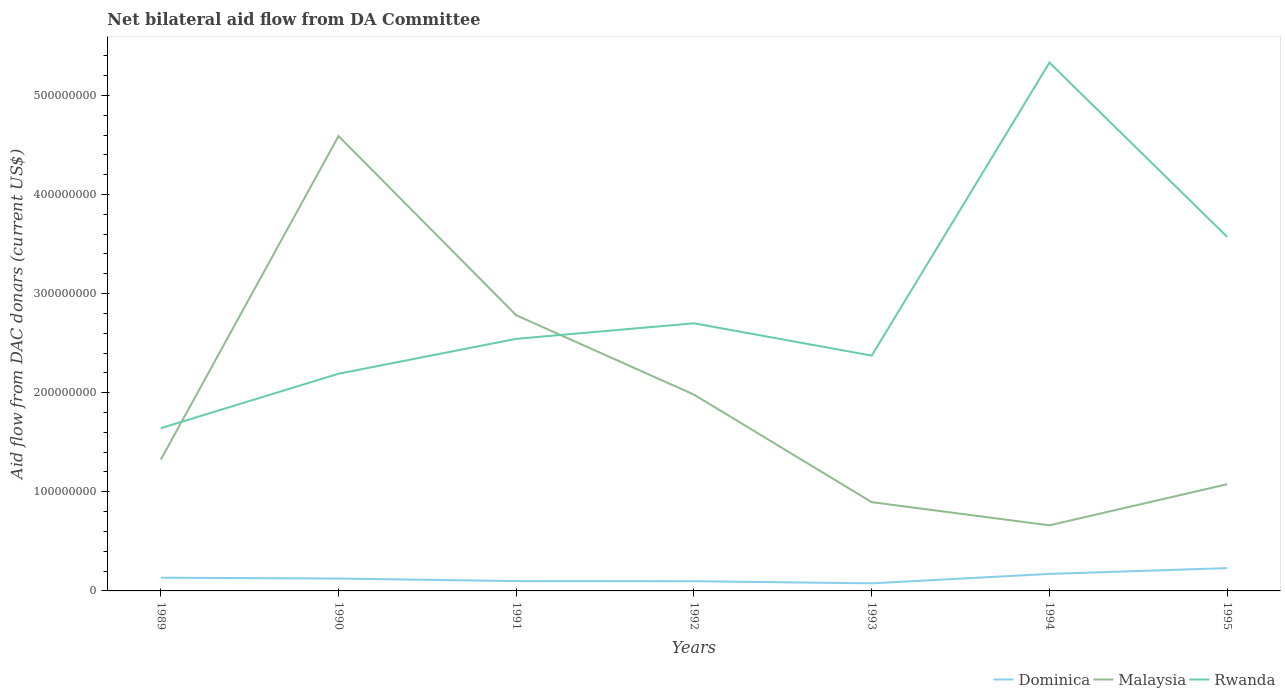Across all years, what is the maximum aid flow in in Rwanda?
Your response must be concise. 1.64e+08. In which year was the aid flow in in Rwanda maximum?
Your response must be concise. 1989. What is the total aid flow in in Dominica in the graph?
Offer a terse response. -1.54e+07. What is the difference between the highest and the second highest aid flow in in Dominica?
Give a very brief answer. 1.54e+07. Is the aid flow in in Rwanda strictly greater than the aid flow in in Malaysia over the years?
Offer a very short reply. No. How many lines are there?
Ensure brevity in your answer.  3. How many years are there in the graph?
Your answer should be very brief. 7. Are the values on the major ticks of Y-axis written in scientific E-notation?
Provide a succinct answer. No. What is the title of the graph?
Offer a very short reply. Net bilateral aid flow from DA Committee. Does "Argentina" appear as one of the legend labels in the graph?
Offer a very short reply. No. What is the label or title of the Y-axis?
Keep it short and to the point. Aid flow from DAC donars (current US$). What is the Aid flow from DAC donars (current US$) in Dominica in 1989?
Keep it short and to the point. 1.33e+07. What is the Aid flow from DAC donars (current US$) of Malaysia in 1989?
Make the answer very short. 1.33e+08. What is the Aid flow from DAC donars (current US$) in Rwanda in 1989?
Your answer should be compact. 1.64e+08. What is the Aid flow from DAC donars (current US$) in Dominica in 1990?
Provide a short and direct response. 1.25e+07. What is the Aid flow from DAC donars (current US$) in Malaysia in 1990?
Ensure brevity in your answer.  4.59e+08. What is the Aid flow from DAC donars (current US$) in Rwanda in 1990?
Your response must be concise. 2.19e+08. What is the Aid flow from DAC donars (current US$) in Dominica in 1991?
Your answer should be very brief. 9.91e+06. What is the Aid flow from DAC donars (current US$) in Malaysia in 1991?
Keep it short and to the point. 2.78e+08. What is the Aid flow from DAC donars (current US$) of Rwanda in 1991?
Your answer should be compact. 2.54e+08. What is the Aid flow from DAC donars (current US$) of Dominica in 1992?
Provide a succinct answer. 9.79e+06. What is the Aid flow from DAC donars (current US$) of Malaysia in 1992?
Keep it short and to the point. 1.98e+08. What is the Aid flow from DAC donars (current US$) in Rwanda in 1992?
Ensure brevity in your answer.  2.70e+08. What is the Aid flow from DAC donars (current US$) in Dominica in 1993?
Keep it short and to the point. 7.65e+06. What is the Aid flow from DAC donars (current US$) in Malaysia in 1993?
Offer a terse response. 8.95e+07. What is the Aid flow from DAC donars (current US$) of Rwanda in 1993?
Make the answer very short. 2.37e+08. What is the Aid flow from DAC donars (current US$) in Dominica in 1994?
Your answer should be very brief. 1.72e+07. What is the Aid flow from DAC donars (current US$) in Malaysia in 1994?
Your answer should be very brief. 6.62e+07. What is the Aid flow from DAC donars (current US$) in Rwanda in 1994?
Keep it short and to the point. 5.33e+08. What is the Aid flow from DAC donars (current US$) of Dominica in 1995?
Your answer should be very brief. 2.30e+07. What is the Aid flow from DAC donars (current US$) of Malaysia in 1995?
Your answer should be compact. 1.08e+08. What is the Aid flow from DAC donars (current US$) of Rwanda in 1995?
Give a very brief answer. 3.57e+08. Across all years, what is the maximum Aid flow from DAC donars (current US$) of Dominica?
Make the answer very short. 2.30e+07. Across all years, what is the maximum Aid flow from DAC donars (current US$) of Malaysia?
Keep it short and to the point. 4.59e+08. Across all years, what is the maximum Aid flow from DAC donars (current US$) in Rwanda?
Your answer should be very brief. 5.33e+08. Across all years, what is the minimum Aid flow from DAC donars (current US$) of Dominica?
Your answer should be very brief. 7.65e+06. Across all years, what is the minimum Aid flow from DAC donars (current US$) in Malaysia?
Keep it short and to the point. 6.62e+07. Across all years, what is the minimum Aid flow from DAC donars (current US$) in Rwanda?
Give a very brief answer. 1.64e+08. What is the total Aid flow from DAC donars (current US$) of Dominica in the graph?
Your response must be concise. 9.34e+07. What is the total Aid flow from DAC donars (current US$) in Malaysia in the graph?
Offer a very short reply. 1.33e+09. What is the total Aid flow from DAC donars (current US$) in Rwanda in the graph?
Offer a terse response. 2.04e+09. What is the difference between the Aid flow from DAC donars (current US$) in Dominica in 1989 and that in 1990?
Offer a terse response. 8.50e+05. What is the difference between the Aid flow from DAC donars (current US$) in Malaysia in 1989 and that in 1990?
Provide a succinct answer. -3.26e+08. What is the difference between the Aid flow from DAC donars (current US$) in Rwanda in 1989 and that in 1990?
Ensure brevity in your answer.  -5.49e+07. What is the difference between the Aid flow from DAC donars (current US$) in Dominica in 1989 and that in 1991?
Your answer should be compact. 3.43e+06. What is the difference between the Aid flow from DAC donars (current US$) in Malaysia in 1989 and that in 1991?
Offer a very short reply. -1.46e+08. What is the difference between the Aid flow from DAC donars (current US$) in Rwanda in 1989 and that in 1991?
Keep it short and to the point. -9.02e+07. What is the difference between the Aid flow from DAC donars (current US$) of Dominica in 1989 and that in 1992?
Ensure brevity in your answer.  3.55e+06. What is the difference between the Aid flow from DAC donars (current US$) in Malaysia in 1989 and that in 1992?
Your response must be concise. -6.55e+07. What is the difference between the Aid flow from DAC donars (current US$) of Rwanda in 1989 and that in 1992?
Keep it short and to the point. -1.06e+08. What is the difference between the Aid flow from DAC donars (current US$) in Dominica in 1989 and that in 1993?
Provide a short and direct response. 5.69e+06. What is the difference between the Aid flow from DAC donars (current US$) in Malaysia in 1989 and that in 1993?
Keep it short and to the point. 4.30e+07. What is the difference between the Aid flow from DAC donars (current US$) of Rwanda in 1989 and that in 1993?
Your answer should be very brief. -7.32e+07. What is the difference between the Aid flow from DAC donars (current US$) of Dominica in 1989 and that in 1994?
Your response must be concise. -3.83e+06. What is the difference between the Aid flow from DAC donars (current US$) of Malaysia in 1989 and that in 1994?
Your answer should be compact. 6.63e+07. What is the difference between the Aid flow from DAC donars (current US$) of Rwanda in 1989 and that in 1994?
Ensure brevity in your answer.  -3.69e+08. What is the difference between the Aid flow from DAC donars (current US$) of Dominica in 1989 and that in 1995?
Your answer should be very brief. -9.68e+06. What is the difference between the Aid flow from DAC donars (current US$) in Malaysia in 1989 and that in 1995?
Your answer should be very brief. 2.49e+07. What is the difference between the Aid flow from DAC donars (current US$) in Rwanda in 1989 and that in 1995?
Provide a succinct answer. -1.93e+08. What is the difference between the Aid flow from DAC donars (current US$) of Dominica in 1990 and that in 1991?
Provide a succinct answer. 2.58e+06. What is the difference between the Aid flow from DAC donars (current US$) in Malaysia in 1990 and that in 1991?
Your answer should be compact. 1.81e+08. What is the difference between the Aid flow from DAC donars (current US$) in Rwanda in 1990 and that in 1991?
Give a very brief answer. -3.52e+07. What is the difference between the Aid flow from DAC donars (current US$) in Dominica in 1990 and that in 1992?
Provide a short and direct response. 2.70e+06. What is the difference between the Aid flow from DAC donars (current US$) of Malaysia in 1990 and that in 1992?
Ensure brevity in your answer.  2.61e+08. What is the difference between the Aid flow from DAC donars (current US$) of Rwanda in 1990 and that in 1992?
Provide a short and direct response. -5.09e+07. What is the difference between the Aid flow from DAC donars (current US$) of Dominica in 1990 and that in 1993?
Your response must be concise. 4.84e+06. What is the difference between the Aid flow from DAC donars (current US$) in Malaysia in 1990 and that in 1993?
Your answer should be very brief. 3.69e+08. What is the difference between the Aid flow from DAC donars (current US$) in Rwanda in 1990 and that in 1993?
Provide a short and direct response. -1.83e+07. What is the difference between the Aid flow from DAC donars (current US$) of Dominica in 1990 and that in 1994?
Keep it short and to the point. -4.68e+06. What is the difference between the Aid flow from DAC donars (current US$) in Malaysia in 1990 and that in 1994?
Ensure brevity in your answer.  3.93e+08. What is the difference between the Aid flow from DAC donars (current US$) in Rwanda in 1990 and that in 1994?
Provide a short and direct response. -3.14e+08. What is the difference between the Aid flow from DAC donars (current US$) of Dominica in 1990 and that in 1995?
Offer a terse response. -1.05e+07. What is the difference between the Aid flow from DAC donars (current US$) of Malaysia in 1990 and that in 1995?
Ensure brevity in your answer.  3.51e+08. What is the difference between the Aid flow from DAC donars (current US$) in Rwanda in 1990 and that in 1995?
Provide a succinct answer. -1.38e+08. What is the difference between the Aid flow from DAC donars (current US$) of Dominica in 1991 and that in 1992?
Make the answer very short. 1.20e+05. What is the difference between the Aid flow from DAC donars (current US$) in Malaysia in 1991 and that in 1992?
Offer a very short reply. 8.01e+07. What is the difference between the Aid flow from DAC donars (current US$) of Rwanda in 1991 and that in 1992?
Your response must be concise. -1.57e+07. What is the difference between the Aid flow from DAC donars (current US$) in Dominica in 1991 and that in 1993?
Your answer should be compact. 2.26e+06. What is the difference between the Aid flow from DAC donars (current US$) of Malaysia in 1991 and that in 1993?
Keep it short and to the point. 1.89e+08. What is the difference between the Aid flow from DAC donars (current US$) of Rwanda in 1991 and that in 1993?
Provide a short and direct response. 1.69e+07. What is the difference between the Aid flow from DAC donars (current US$) in Dominica in 1991 and that in 1994?
Offer a very short reply. -7.26e+06. What is the difference between the Aid flow from DAC donars (current US$) in Malaysia in 1991 and that in 1994?
Provide a succinct answer. 2.12e+08. What is the difference between the Aid flow from DAC donars (current US$) in Rwanda in 1991 and that in 1994?
Offer a terse response. -2.79e+08. What is the difference between the Aid flow from DAC donars (current US$) in Dominica in 1991 and that in 1995?
Provide a succinct answer. -1.31e+07. What is the difference between the Aid flow from DAC donars (current US$) in Malaysia in 1991 and that in 1995?
Give a very brief answer. 1.70e+08. What is the difference between the Aid flow from DAC donars (current US$) in Rwanda in 1991 and that in 1995?
Provide a short and direct response. -1.03e+08. What is the difference between the Aid flow from DAC donars (current US$) of Dominica in 1992 and that in 1993?
Give a very brief answer. 2.14e+06. What is the difference between the Aid flow from DAC donars (current US$) of Malaysia in 1992 and that in 1993?
Give a very brief answer. 1.09e+08. What is the difference between the Aid flow from DAC donars (current US$) in Rwanda in 1992 and that in 1993?
Offer a terse response. 3.26e+07. What is the difference between the Aid flow from DAC donars (current US$) of Dominica in 1992 and that in 1994?
Keep it short and to the point. -7.38e+06. What is the difference between the Aid flow from DAC donars (current US$) in Malaysia in 1992 and that in 1994?
Ensure brevity in your answer.  1.32e+08. What is the difference between the Aid flow from DAC donars (current US$) in Rwanda in 1992 and that in 1994?
Provide a short and direct response. -2.63e+08. What is the difference between the Aid flow from DAC donars (current US$) of Dominica in 1992 and that in 1995?
Offer a very short reply. -1.32e+07. What is the difference between the Aid flow from DAC donars (current US$) of Malaysia in 1992 and that in 1995?
Keep it short and to the point. 9.04e+07. What is the difference between the Aid flow from DAC donars (current US$) of Rwanda in 1992 and that in 1995?
Your response must be concise. -8.72e+07. What is the difference between the Aid flow from DAC donars (current US$) in Dominica in 1993 and that in 1994?
Provide a succinct answer. -9.52e+06. What is the difference between the Aid flow from DAC donars (current US$) in Malaysia in 1993 and that in 1994?
Your response must be concise. 2.33e+07. What is the difference between the Aid flow from DAC donars (current US$) of Rwanda in 1993 and that in 1994?
Your response must be concise. -2.96e+08. What is the difference between the Aid flow from DAC donars (current US$) of Dominica in 1993 and that in 1995?
Offer a terse response. -1.54e+07. What is the difference between the Aid flow from DAC donars (current US$) in Malaysia in 1993 and that in 1995?
Offer a very short reply. -1.81e+07. What is the difference between the Aid flow from DAC donars (current US$) of Rwanda in 1993 and that in 1995?
Your answer should be very brief. -1.20e+08. What is the difference between the Aid flow from DAC donars (current US$) in Dominica in 1994 and that in 1995?
Offer a terse response. -5.85e+06. What is the difference between the Aid flow from DAC donars (current US$) in Malaysia in 1994 and that in 1995?
Keep it short and to the point. -4.14e+07. What is the difference between the Aid flow from DAC donars (current US$) of Rwanda in 1994 and that in 1995?
Offer a very short reply. 1.76e+08. What is the difference between the Aid flow from DAC donars (current US$) in Dominica in 1989 and the Aid flow from DAC donars (current US$) in Malaysia in 1990?
Offer a terse response. -4.46e+08. What is the difference between the Aid flow from DAC donars (current US$) in Dominica in 1989 and the Aid flow from DAC donars (current US$) in Rwanda in 1990?
Ensure brevity in your answer.  -2.06e+08. What is the difference between the Aid flow from DAC donars (current US$) of Malaysia in 1989 and the Aid flow from DAC donars (current US$) of Rwanda in 1990?
Ensure brevity in your answer.  -8.66e+07. What is the difference between the Aid flow from DAC donars (current US$) in Dominica in 1989 and the Aid flow from DAC donars (current US$) in Malaysia in 1991?
Offer a terse response. -2.65e+08. What is the difference between the Aid flow from DAC donars (current US$) in Dominica in 1989 and the Aid flow from DAC donars (current US$) in Rwanda in 1991?
Your answer should be very brief. -2.41e+08. What is the difference between the Aid flow from DAC donars (current US$) of Malaysia in 1989 and the Aid flow from DAC donars (current US$) of Rwanda in 1991?
Make the answer very short. -1.22e+08. What is the difference between the Aid flow from DAC donars (current US$) of Dominica in 1989 and the Aid flow from DAC donars (current US$) of Malaysia in 1992?
Make the answer very short. -1.85e+08. What is the difference between the Aid flow from DAC donars (current US$) of Dominica in 1989 and the Aid flow from DAC donars (current US$) of Rwanda in 1992?
Provide a short and direct response. -2.57e+08. What is the difference between the Aid flow from DAC donars (current US$) in Malaysia in 1989 and the Aid flow from DAC donars (current US$) in Rwanda in 1992?
Provide a succinct answer. -1.38e+08. What is the difference between the Aid flow from DAC donars (current US$) in Dominica in 1989 and the Aid flow from DAC donars (current US$) in Malaysia in 1993?
Your response must be concise. -7.62e+07. What is the difference between the Aid flow from DAC donars (current US$) in Dominica in 1989 and the Aid flow from DAC donars (current US$) in Rwanda in 1993?
Your response must be concise. -2.24e+08. What is the difference between the Aid flow from DAC donars (current US$) of Malaysia in 1989 and the Aid flow from DAC donars (current US$) of Rwanda in 1993?
Make the answer very short. -1.05e+08. What is the difference between the Aid flow from DAC donars (current US$) of Dominica in 1989 and the Aid flow from DAC donars (current US$) of Malaysia in 1994?
Keep it short and to the point. -5.29e+07. What is the difference between the Aid flow from DAC donars (current US$) in Dominica in 1989 and the Aid flow from DAC donars (current US$) in Rwanda in 1994?
Keep it short and to the point. -5.20e+08. What is the difference between the Aid flow from DAC donars (current US$) in Malaysia in 1989 and the Aid flow from DAC donars (current US$) in Rwanda in 1994?
Your answer should be very brief. -4.01e+08. What is the difference between the Aid flow from DAC donars (current US$) in Dominica in 1989 and the Aid flow from DAC donars (current US$) in Malaysia in 1995?
Give a very brief answer. -9.43e+07. What is the difference between the Aid flow from DAC donars (current US$) in Dominica in 1989 and the Aid flow from DAC donars (current US$) in Rwanda in 1995?
Offer a terse response. -3.44e+08. What is the difference between the Aid flow from DAC donars (current US$) of Malaysia in 1989 and the Aid flow from DAC donars (current US$) of Rwanda in 1995?
Give a very brief answer. -2.25e+08. What is the difference between the Aid flow from DAC donars (current US$) of Dominica in 1990 and the Aid flow from DAC donars (current US$) of Malaysia in 1991?
Offer a terse response. -2.66e+08. What is the difference between the Aid flow from DAC donars (current US$) of Dominica in 1990 and the Aid flow from DAC donars (current US$) of Rwanda in 1991?
Provide a short and direct response. -2.42e+08. What is the difference between the Aid flow from DAC donars (current US$) of Malaysia in 1990 and the Aid flow from DAC donars (current US$) of Rwanda in 1991?
Offer a terse response. 2.05e+08. What is the difference between the Aid flow from DAC donars (current US$) of Dominica in 1990 and the Aid flow from DAC donars (current US$) of Malaysia in 1992?
Give a very brief answer. -1.86e+08. What is the difference between the Aid flow from DAC donars (current US$) in Dominica in 1990 and the Aid flow from DAC donars (current US$) in Rwanda in 1992?
Your answer should be compact. -2.58e+08. What is the difference between the Aid flow from DAC donars (current US$) in Malaysia in 1990 and the Aid flow from DAC donars (current US$) in Rwanda in 1992?
Ensure brevity in your answer.  1.89e+08. What is the difference between the Aid flow from DAC donars (current US$) in Dominica in 1990 and the Aid flow from DAC donars (current US$) in Malaysia in 1993?
Provide a short and direct response. -7.70e+07. What is the difference between the Aid flow from DAC donars (current US$) in Dominica in 1990 and the Aid flow from DAC donars (current US$) in Rwanda in 1993?
Provide a succinct answer. -2.25e+08. What is the difference between the Aid flow from DAC donars (current US$) of Malaysia in 1990 and the Aid flow from DAC donars (current US$) of Rwanda in 1993?
Offer a very short reply. 2.22e+08. What is the difference between the Aid flow from DAC donars (current US$) of Dominica in 1990 and the Aid flow from DAC donars (current US$) of Malaysia in 1994?
Offer a very short reply. -5.37e+07. What is the difference between the Aid flow from DAC donars (current US$) of Dominica in 1990 and the Aid flow from DAC donars (current US$) of Rwanda in 1994?
Ensure brevity in your answer.  -5.21e+08. What is the difference between the Aid flow from DAC donars (current US$) in Malaysia in 1990 and the Aid flow from DAC donars (current US$) in Rwanda in 1994?
Your answer should be compact. -7.41e+07. What is the difference between the Aid flow from DAC donars (current US$) in Dominica in 1990 and the Aid flow from DAC donars (current US$) in Malaysia in 1995?
Your response must be concise. -9.52e+07. What is the difference between the Aid flow from DAC donars (current US$) in Dominica in 1990 and the Aid flow from DAC donars (current US$) in Rwanda in 1995?
Offer a terse response. -3.45e+08. What is the difference between the Aid flow from DAC donars (current US$) of Malaysia in 1990 and the Aid flow from DAC donars (current US$) of Rwanda in 1995?
Keep it short and to the point. 1.02e+08. What is the difference between the Aid flow from DAC donars (current US$) in Dominica in 1991 and the Aid flow from DAC donars (current US$) in Malaysia in 1992?
Your answer should be very brief. -1.88e+08. What is the difference between the Aid flow from DAC donars (current US$) of Dominica in 1991 and the Aid flow from DAC donars (current US$) of Rwanda in 1992?
Offer a terse response. -2.60e+08. What is the difference between the Aid flow from DAC donars (current US$) in Malaysia in 1991 and the Aid flow from DAC donars (current US$) in Rwanda in 1992?
Give a very brief answer. 8.09e+06. What is the difference between the Aid flow from DAC donars (current US$) of Dominica in 1991 and the Aid flow from DAC donars (current US$) of Malaysia in 1993?
Keep it short and to the point. -7.96e+07. What is the difference between the Aid flow from DAC donars (current US$) of Dominica in 1991 and the Aid flow from DAC donars (current US$) of Rwanda in 1993?
Provide a succinct answer. -2.28e+08. What is the difference between the Aid flow from DAC donars (current US$) in Malaysia in 1991 and the Aid flow from DAC donars (current US$) in Rwanda in 1993?
Keep it short and to the point. 4.07e+07. What is the difference between the Aid flow from DAC donars (current US$) in Dominica in 1991 and the Aid flow from DAC donars (current US$) in Malaysia in 1994?
Your response must be concise. -5.63e+07. What is the difference between the Aid flow from DAC donars (current US$) in Dominica in 1991 and the Aid flow from DAC donars (current US$) in Rwanda in 1994?
Your answer should be very brief. -5.23e+08. What is the difference between the Aid flow from DAC donars (current US$) of Malaysia in 1991 and the Aid flow from DAC donars (current US$) of Rwanda in 1994?
Provide a succinct answer. -2.55e+08. What is the difference between the Aid flow from DAC donars (current US$) of Dominica in 1991 and the Aid flow from DAC donars (current US$) of Malaysia in 1995?
Offer a terse response. -9.77e+07. What is the difference between the Aid flow from DAC donars (current US$) of Dominica in 1991 and the Aid flow from DAC donars (current US$) of Rwanda in 1995?
Keep it short and to the point. -3.47e+08. What is the difference between the Aid flow from DAC donars (current US$) of Malaysia in 1991 and the Aid flow from DAC donars (current US$) of Rwanda in 1995?
Offer a very short reply. -7.91e+07. What is the difference between the Aid flow from DAC donars (current US$) in Dominica in 1992 and the Aid flow from DAC donars (current US$) in Malaysia in 1993?
Make the answer very short. -7.98e+07. What is the difference between the Aid flow from DAC donars (current US$) of Dominica in 1992 and the Aid flow from DAC donars (current US$) of Rwanda in 1993?
Provide a short and direct response. -2.28e+08. What is the difference between the Aid flow from DAC donars (current US$) in Malaysia in 1992 and the Aid flow from DAC donars (current US$) in Rwanda in 1993?
Ensure brevity in your answer.  -3.94e+07. What is the difference between the Aid flow from DAC donars (current US$) of Dominica in 1992 and the Aid flow from DAC donars (current US$) of Malaysia in 1994?
Your answer should be compact. -5.64e+07. What is the difference between the Aid flow from DAC donars (current US$) in Dominica in 1992 and the Aid flow from DAC donars (current US$) in Rwanda in 1994?
Your answer should be compact. -5.23e+08. What is the difference between the Aid flow from DAC donars (current US$) of Malaysia in 1992 and the Aid flow from DAC donars (current US$) of Rwanda in 1994?
Give a very brief answer. -3.35e+08. What is the difference between the Aid flow from DAC donars (current US$) of Dominica in 1992 and the Aid flow from DAC donars (current US$) of Malaysia in 1995?
Ensure brevity in your answer.  -9.78e+07. What is the difference between the Aid flow from DAC donars (current US$) in Dominica in 1992 and the Aid flow from DAC donars (current US$) in Rwanda in 1995?
Your answer should be very brief. -3.47e+08. What is the difference between the Aid flow from DAC donars (current US$) in Malaysia in 1992 and the Aid flow from DAC donars (current US$) in Rwanda in 1995?
Your answer should be compact. -1.59e+08. What is the difference between the Aid flow from DAC donars (current US$) in Dominica in 1993 and the Aid flow from DAC donars (current US$) in Malaysia in 1994?
Your answer should be very brief. -5.86e+07. What is the difference between the Aid flow from DAC donars (current US$) of Dominica in 1993 and the Aid flow from DAC donars (current US$) of Rwanda in 1994?
Your response must be concise. -5.25e+08. What is the difference between the Aid flow from DAC donars (current US$) of Malaysia in 1993 and the Aid flow from DAC donars (current US$) of Rwanda in 1994?
Make the answer very short. -4.44e+08. What is the difference between the Aid flow from DAC donars (current US$) in Dominica in 1993 and the Aid flow from DAC donars (current US$) in Malaysia in 1995?
Your response must be concise. -1.00e+08. What is the difference between the Aid flow from DAC donars (current US$) of Dominica in 1993 and the Aid flow from DAC donars (current US$) of Rwanda in 1995?
Your answer should be very brief. -3.50e+08. What is the difference between the Aid flow from DAC donars (current US$) of Malaysia in 1993 and the Aid flow from DAC donars (current US$) of Rwanda in 1995?
Keep it short and to the point. -2.68e+08. What is the difference between the Aid flow from DAC donars (current US$) of Dominica in 1994 and the Aid flow from DAC donars (current US$) of Malaysia in 1995?
Offer a very short reply. -9.05e+07. What is the difference between the Aid flow from DAC donars (current US$) of Dominica in 1994 and the Aid flow from DAC donars (current US$) of Rwanda in 1995?
Give a very brief answer. -3.40e+08. What is the difference between the Aid flow from DAC donars (current US$) in Malaysia in 1994 and the Aid flow from DAC donars (current US$) in Rwanda in 1995?
Your answer should be compact. -2.91e+08. What is the average Aid flow from DAC donars (current US$) of Dominica per year?
Ensure brevity in your answer.  1.33e+07. What is the average Aid flow from DAC donars (current US$) of Malaysia per year?
Keep it short and to the point. 1.90e+08. What is the average Aid flow from DAC donars (current US$) of Rwanda per year?
Provide a short and direct response. 2.91e+08. In the year 1989, what is the difference between the Aid flow from DAC donars (current US$) in Dominica and Aid flow from DAC donars (current US$) in Malaysia?
Make the answer very short. -1.19e+08. In the year 1989, what is the difference between the Aid flow from DAC donars (current US$) of Dominica and Aid flow from DAC donars (current US$) of Rwanda?
Keep it short and to the point. -1.51e+08. In the year 1989, what is the difference between the Aid flow from DAC donars (current US$) in Malaysia and Aid flow from DAC donars (current US$) in Rwanda?
Your answer should be very brief. -3.17e+07. In the year 1990, what is the difference between the Aid flow from DAC donars (current US$) of Dominica and Aid flow from DAC donars (current US$) of Malaysia?
Ensure brevity in your answer.  -4.46e+08. In the year 1990, what is the difference between the Aid flow from DAC donars (current US$) in Dominica and Aid flow from DAC donars (current US$) in Rwanda?
Your answer should be compact. -2.07e+08. In the year 1990, what is the difference between the Aid flow from DAC donars (current US$) in Malaysia and Aid flow from DAC donars (current US$) in Rwanda?
Your answer should be very brief. 2.40e+08. In the year 1991, what is the difference between the Aid flow from DAC donars (current US$) of Dominica and Aid flow from DAC donars (current US$) of Malaysia?
Offer a terse response. -2.68e+08. In the year 1991, what is the difference between the Aid flow from DAC donars (current US$) of Dominica and Aid flow from DAC donars (current US$) of Rwanda?
Keep it short and to the point. -2.44e+08. In the year 1991, what is the difference between the Aid flow from DAC donars (current US$) in Malaysia and Aid flow from DAC donars (current US$) in Rwanda?
Offer a very short reply. 2.38e+07. In the year 1992, what is the difference between the Aid flow from DAC donars (current US$) in Dominica and Aid flow from DAC donars (current US$) in Malaysia?
Provide a short and direct response. -1.88e+08. In the year 1992, what is the difference between the Aid flow from DAC donars (current US$) of Dominica and Aid flow from DAC donars (current US$) of Rwanda?
Ensure brevity in your answer.  -2.60e+08. In the year 1992, what is the difference between the Aid flow from DAC donars (current US$) of Malaysia and Aid flow from DAC donars (current US$) of Rwanda?
Your answer should be very brief. -7.20e+07. In the year 1993, what is the difference between the Aid flow from DAC donars (current US$) of Dominica and Aid flow from DAC donars (current US$) of Malaysia?
Offer a very short reply. -8.19e+07. In the year 1993, what is the difference between the Aid flow from DAC donars (current US$) in Dominica and Aid flow from DAC donars (current US$) in Rwanda?
Your answer should be compact. -2.30e+08. In the year 1993, what is the difference between the Aid flow from DAC donars (current US$) of Malaysia and Aid flow from DAC donars (current US$) of Rwanda?
Offer a terse response. -1.48e+08. In the year 1994, what is the difference between the Aid flow from DAC donars (current US$) of Dominica and Aid flow from DAC donars (current US$) of Malaysia?
Your answer should be compact. -4.90e+07. In the year 1994, what is the difference between the Aid flow from DAC donars (current US$) in Dominica and Aid flow from DAC donars (current US$) in Rwanda?
Ensure brevity in your answer.  -5.16e+08. In the year 1994, what is the difference between the Aid flow from DAC donars (current US$) of Malaysia and Aid flow from DAC donars (current US$) of Rwanda?
Your answer should be very brief. -4.67e+08. In the year 1995, what is the difference between the Aid flow from DAC donars (current US$) of Dominica and Aid flow from DAC donars (current US$) of Malaysia?
Your answer should be compact. -8.46e+07. In the year 1995, what is the difference between the Aid flow from DAC donars (current US$) of Dominica and Aid flow from DAC donars (current US$) of Rwanda?
Your answer should be compact. -3.34e+08. In the year 1995, what is the difference between the Aid flow from DAC donars (current US$) in Malaysia and Aid flow from DAC donars (current US$) in Rwanda?
Keep it short and to the point. -2.50e+08. What is the ratio of the Aid flow from DAC donars (current US$) of Dominica in 1989 to that in 1990?
Offer a terse response. 1.07. What is the ratio of the Aid flow from DAC donars (current US$) in Malaysia in 1989 to that in 1990?
Offer a terse response. 0.29. What is the ratio of the Aid flow from DAC donars (current US$) in Rwanda in 1989 to that in 1990?
Your response must be concise. 0.75. What is the ratio of the Aid flow from DAC donars (current US$) of Dominica in 1989 to that in 1991?
Offer a very short reply. 1.35. What is the ratio of the Aid flow from DAC donars (current US$) in Malaysia in 1989 to that in 1991?
Offer a terse response. 0.48. What is the ratio of the Aid flow from DAC donars (current US$) in Rwanda in 1989 to that in 1991?
Provide a succinct answer. 0.65. What is the ratio of the Aid flow from DAC donars (current US$) in Dominica in 1989 to that in 1992?
Make the answer very short. 1.36. What is the ratio of the Aid flow from DAC donars (current US$) in Malaysia in 1989 to that in 1992?
Your answer should be very brief. 0.67. What is the ratio of the Aid flow from DAC donars (current US$) of Rwanda in 1989 to that in 1992?
Your answer should be very brief. 0.61. What is the ratio of the Aid flow from DAC donars (current US$) in Dominica in 1989 to that in 1993?
Your answer should be compact. 1.74. What is the ratio of the Aid flow from DAC donars (current US$) of Malaysia in 1989 to that in 1993?
Your answer should be compact. 1.48. What is the ratio of the Aid flow from DAC donars (current US$) in Rwanda in 1989 to that in 1993?
Give a very brief answer. 0.69. What is the ratio of the Aid flow from DAC donars (current US$) in Dominica in 1989 to that in 1994?
Keep it short and to the point. 0.78. What is the ratio of the Aid flow from DAC donars (current US$) in Malaysia in 1989 to that in 1994?
Keep it short and to the point. 2. What is the ratio of the Aid flow from DAC donars (current US$) of Rwanda in 1989 to that in 1994?
Ensure brevity in your answer.  0.31. What is the ratio of the Aid flow from DAC donars (current US$) of Dominica in 1989 to that in 1995?
Make the answer very short. 0.58. What is the ratio of the Aid flow from DAC donars (current US$) in Malaysia in 1989 to that in 1995?
Give a very brief answer. 1.23. What is the ratio of the Aid flow from DAC donars (current US$) in Rwanda in 1989 to that in 1995?
Provide a short and direct response. 0.46. What is the ratio of the Aid flow from DAC donars (current US$) in Dominica in 1990 to that in 1991?
Give a very brief answer. 1.26. What is the ratio of the Aid flow from DAC donars (current US$) in Malaysia in 1990 to that in 1991?
Make the answer very short. 1.65. What is the ratio of the Aid flow from DAC donars (current US$) of Rwanda in 1990 to that in 1991?
Provide a succinct answer. 0.86. What is the ratio of the Aid flow from DAC donars (current US$) of Dominica in 1990 to that in 1992?
Give a very brief answer. 1.28. What is the ratio of the Aid flow from DAC donars (current US$) in Malaysia in 1990 to that in 1992?
Offer a terse response. 2.32. What is the ratio of the Aid flow from DAC donars (current US$) in Rwanda in 1990 to that in 1992?
Offer a very short reply. 0.81. What is the ratio of the Aid flow from DAC donars (current US$) in Dominica in 1990 to that in 1993?
Your response must be concise. 1.63. What is the ratio of the Aid flow from DAC donars (current US$) in Malaysia in 1990 to that in 1993?
Offer a terse response. 5.13. What is the ratio of the Aid flow from DAC donars (current US$) in Rwanda in 1990 to that in 1993?
Provide a short and direct response. 0.92. What is the ratio of the Aid flow from DAC donars (current US$) of Dominica in 1990 to that in 1994?
Ensure brevity in your answer.  0.73. What is the ratio of the Aid flow from DAC donars (current US$) of Malaysia in 1990 to that in 1994?
Make the answer very short. 6.93. What is the ratio of the Aid flow from DAC donars (current US$) of Rwanda in 1990 to that in 1994?
Offer a terse response. 0.41. What is the ratio of the Aid flow from DAC donars (current US$) of Dominica in 1990 to that in 1995?
Your response must be concise. 0.54. What is the ratio of the Aid flow from DAC donars (current US$) in Malaysia in 1990 to that in 1995?
Ensure brevity in your answer.  4.26. What is the ratio of the Aid flow from DAC donars (current US$) in Rwanda in 1990 to that in 1995?
Provide a succinct answer. 0.61. What is the ratio of the Aid flow from DAC donars (current US$) in Dominica in 1991 to that in 1992?
Make the answer very short. 1.01. What is the ratio of the Aid flow from DAC donars (current US$) of Malaysia in 1991 to that in 1992?
Offer a very short reply. 1.4. What is the ratio of the Aid flow from DAC donars (current US$) of Rwanda in 1991 to that in 1992?
Make the answer very short. 0.94. What is the ratio of the Aid flow from DAC donars (current US$) of Dominica in 1991 to that in 1993?
Provide a succinct answer. 1.3. What is the ratio of the Aid flow from DAC donars (current US$) in Malaysia in 1991 to that in 1993?
Make the answer very short. 3.11. What is the ratio of the Aid flow from DAC donars (current US$) of Rwanda in 1991 to that in 1993?
Offer a terse response. 1.07. What is the ratio of the Aid flow from DAC donars (current US$) of Dominica in 1991 to that in 1994?
Give a very brief answer. 0.58. What is the ratio of the Aid flow from DAC donars (current US$) in Malaysia in 1991 to that in 1994?
Provide a short and direct response. 4.2. What is the ratio of the Aid flow from DAC donars (current US$) in Rwanda in 1991 to that in 1994?
Your response must be concise. 0.48. What is the ratio of the Aid flow from DAC donars (current US$) of Dominica in 1991 to that in 1995?
Give a very brief answer. 0.43. What is the ratio of the Aid flow from DAC donars (current US$) of Malaysia in 1991 to that in 1995?
Your answer should be very brief. 2.58. What is the ratio of the Aid flow from DAC donars (current US$) in Rwanda in 1991 to that in 1995?
Your response must be concise. 0.71. What is the ratio of the Aid flow from DAC donars (current US$) of Dominica in 1992 to that in 1993?
Your answer should be compact. 1.28. What is the ratio of the Aid flow from DAC donars (current US$) in Malaysia in 1992 to that in 1993?
Your response must be concise. 2.21. What is the ratio of the Aid flow from DAC donars (current US$) of Rwanda in 1992 to that in 1993?
Keep it short and to the point. 1.14. What is the ratio of the Aid flow from DAC donars (current US$) in Dominica in 1992 to that in 1994?
Your answer should be compact. 0.57. What is the ratio of the Aid flow from DAC donars (current US$) of Malaysia in 1992 to that in 1994?
Your answer should be very brief. 2.99. What is the ratio of the Aid flow from DAC donars (current US$) in Rwanda in 1992 to that in 1994?
Ensure brevity in your answer.  0.51. What is the ratio of the Aid flow from DAC donars (current US$) in Dominica in 1992 to that in 1995?
Keep it short and to the point. 0.43. What is the ratio of the Aid flow from DAC donars (current US$) of Malaysia in 1992 to that in 1995?
Your response must be concise. 1.84. What is the ratio of the Aid flow from DAC donars (current US$) of Rwanda in 1992 to that in 1995?
Keep it short and to the point. 0.76. What is the ratio of the Aid flow from DAC donars (current US$) of Dominica in 1993 to that in 1994?
Offer a terse response. 0.45. What is the ratio of the Aid flow from DAC donars (current US$) of Malaysia in 1993 to that in 1994?
Give a very brief answer. 1.35. What is the ratio of the Aid flow from DAC donars (current US$) in Rwanda in 1993 to that in 1994?
Ensure brevity in your answer.  0.45. What is the ratio of the Aid flow from DAC donars (current US$) of Dominica in 1993 to that in 1995?
Give a very brief answer. 0.33. What is the ratio of the Aid flow from DAC donars (current US$) of Malaysia in 1993 to that in 1995?
Make the answer very short. 0.83. What is the ratio of the Aid flow from DAC donars (current US$) of Rwanda in 1993 to that in 1995?
Keep it short and to the point. 0.66. What is the ratio of the Aid flow from DAC donars (current US$) in Dominica in 1994 to that in 1995?
Your response must be concise. 0.75. What is the ratio of the Aid flow from DAC donars (current US$) in Malaysia in 1994 to that in 1995?
Ensure brevity in your answer.  0.61. What is the ratio of the Aid flow from DAC donars (current US$) of Rwanda in 1994 to that in 1995?
Provide a succinct answer. 1.49. What is the difference between the highest and the second highest Aid flow from DAC donars (current US$) of Dominica?
Offer a very short reply. 5.85e+06. What is the difference between the highest and the second highest Aid flow from DAC donars (current US$) in Malaysia?
Provide a succinct answer. 1.81e+08. What is the difference between the highest and the second highest Aid flow from DAC donars (current US$) in Rwanda?
Offer a very short reply. 1.76e+08. What is the difference between the highest and the lowest Aid flow from DAC donars (current US$) in Dominica?
Offer a terse response. 1.54e+07. What is the difference between the highest and the lowest Aid flow from DAC donars (current US$) of Malaysia?
Your answer should be compact. 3.93e+08. What is the difference between the highest and the lowest Aid flow from DAC donars (current US$) of Rwanda?
Offer a very short reply. 3.69e+08. 